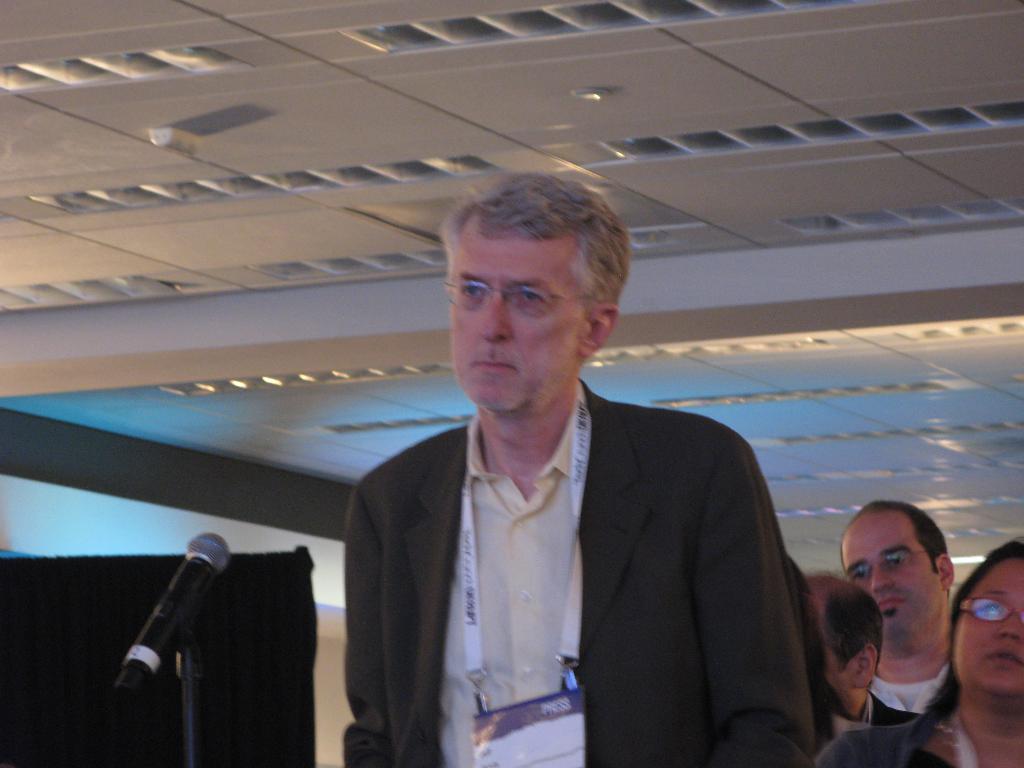Please provide a concise description of this image. In this image there is a person. In front of him there is a mike. Behind him there are a few other people. On the left side of the image there is a black color cloth. On top of the image there is a light. 